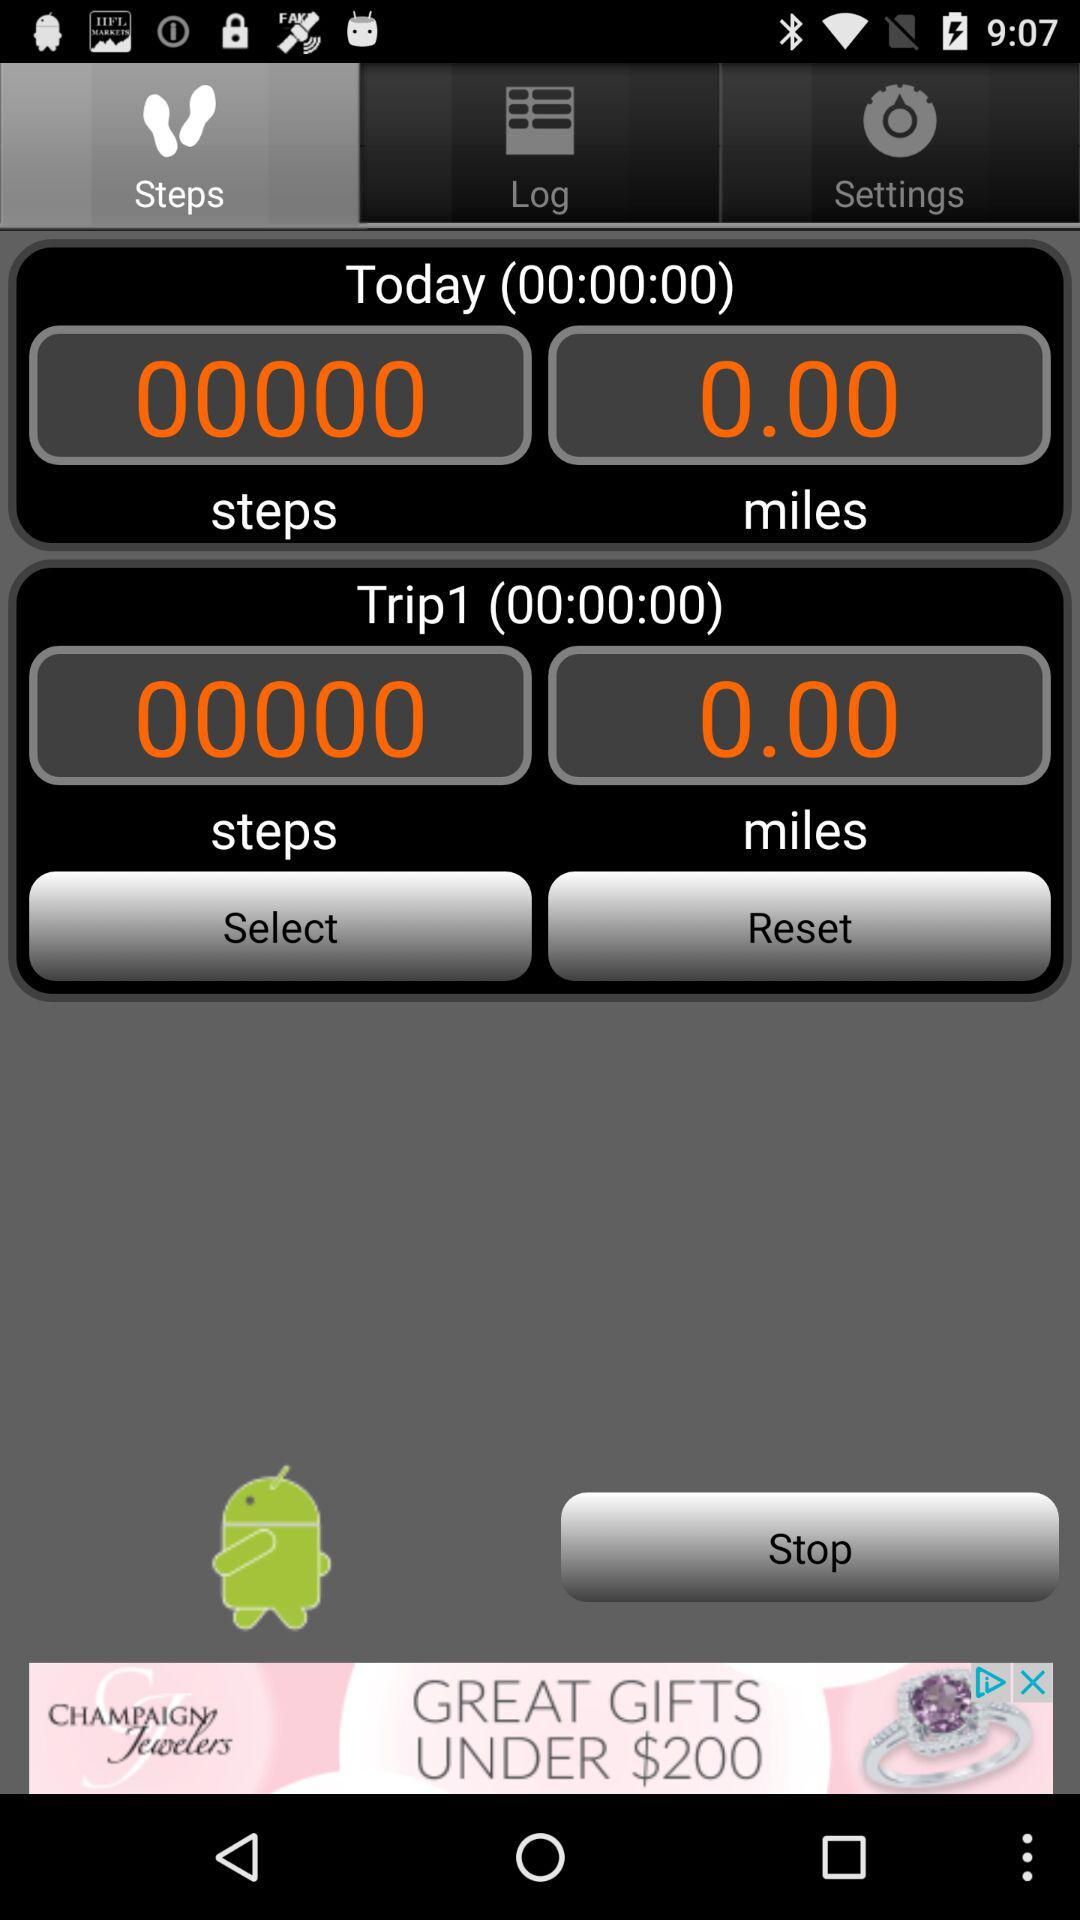Which tab is currently selected? The currently selected tab is "Steps". 